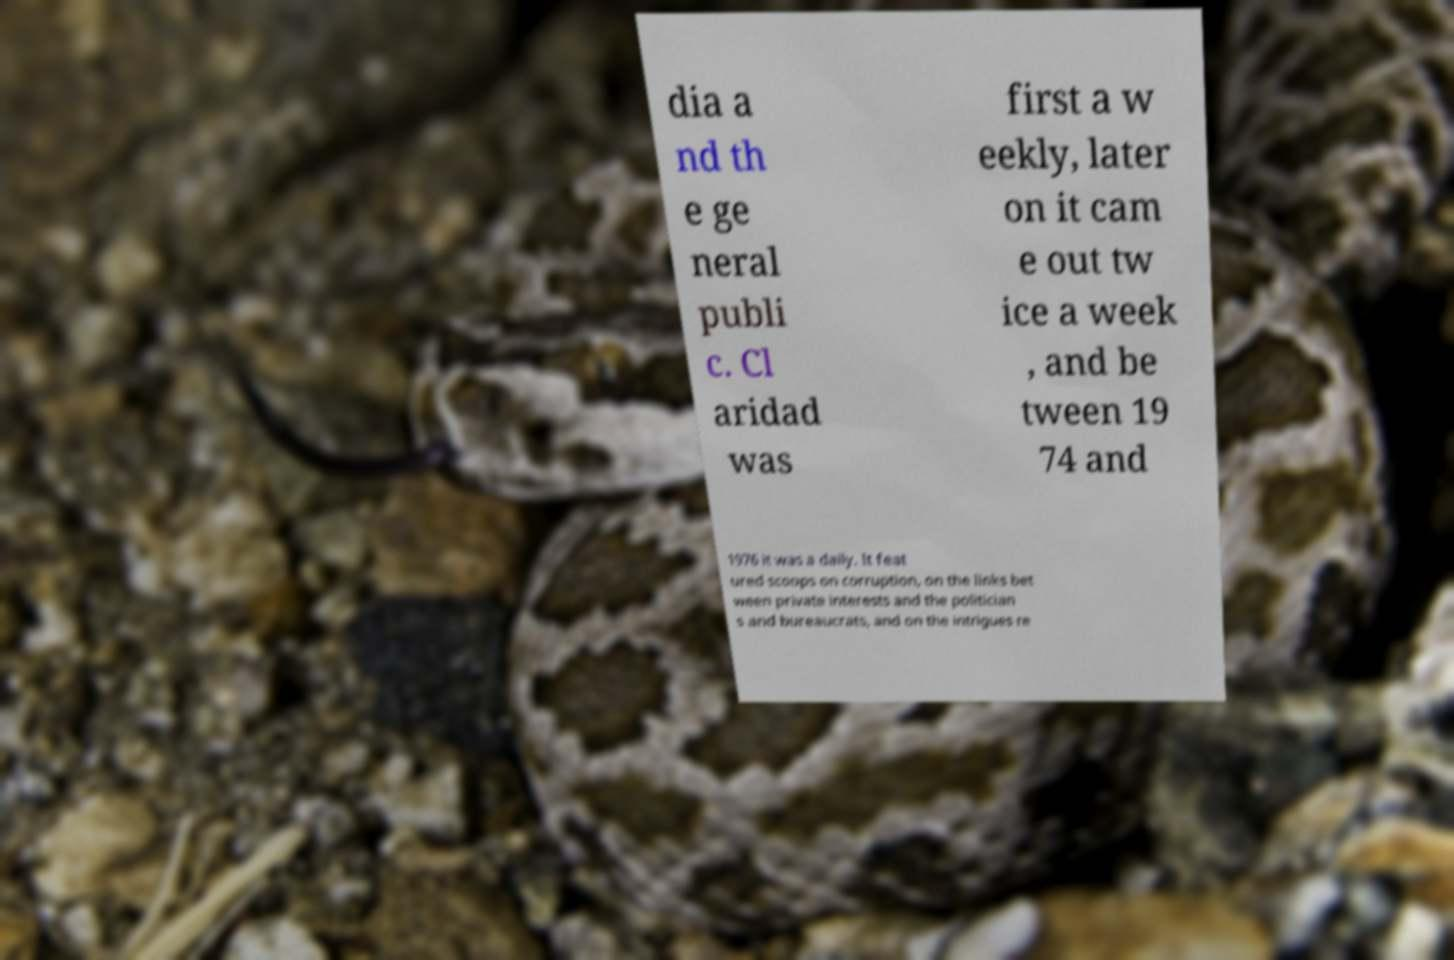Can you accurately transcribe the text from the provided image for me? dia a nd th e ge neral publi c. Cl aridad was first a w eekly, later on it cam e out tw ice a week , and be tween 19 74 and 1976 it was a daily. It feat ured scoops on corruption, on the links bet ween private interests and the politician s and bureaucrats, and on the intrigues re 